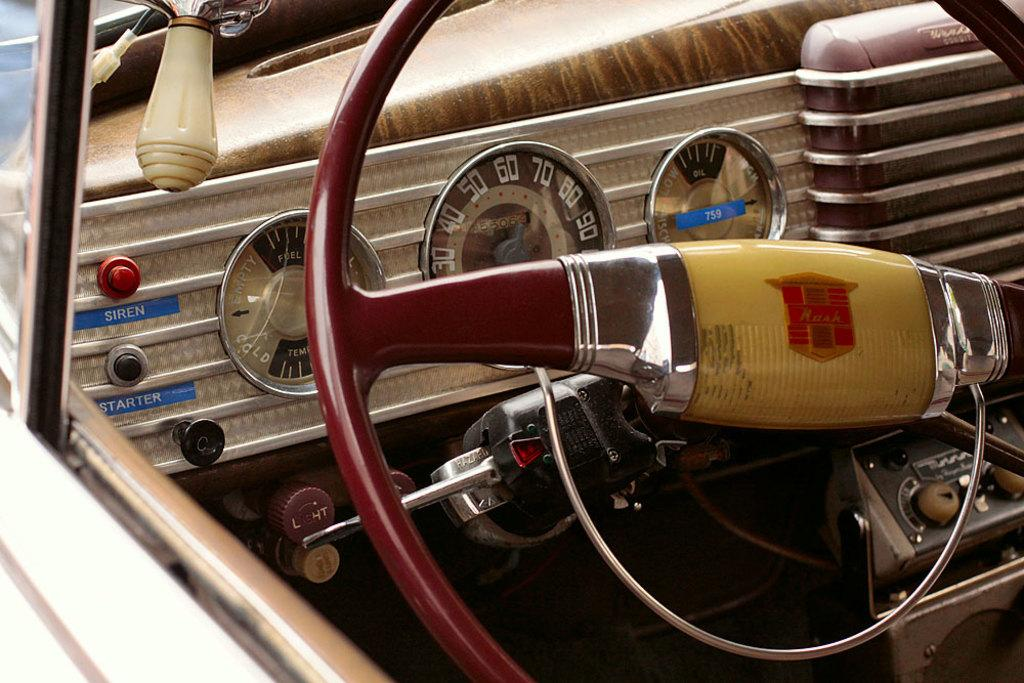What is the main object in the image? There is a steering wheel in the image. What other car-related elements can be seen in the image? There are indicators and a horn visible in the image. What type of vehicle might these elements belong to? All these elements are present in a car. Can you tell me how deep the edge of the recess is in the image? There is no recess present in the image; it features elements of a car. How many laps can the swim be completed in the image? There is no swimming activity depicted in the image; it features elements of a car. 